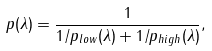<formula> <loc_0><loc_0><loc_500><loc_500>p ( \lambda ) = \frac { 1 } { 1 / p _ { l o w } ( \lambda ) + 1 / p _ { h i g h } ( \lambda ) } ,</formula> 